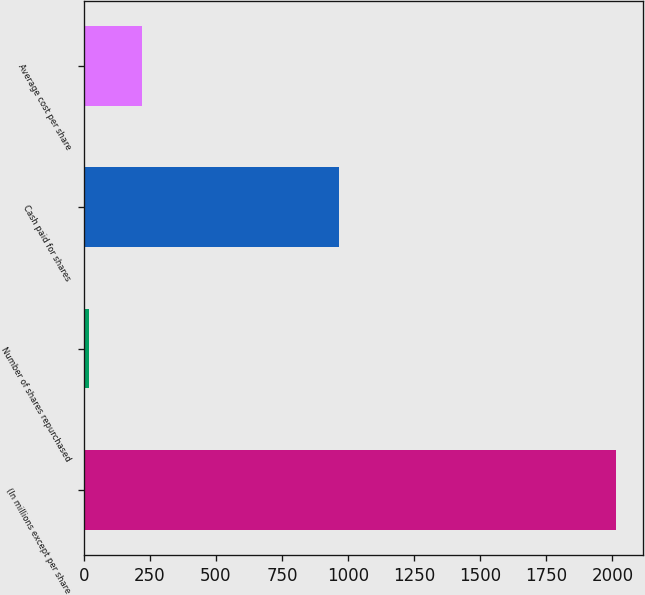<chart> <loc_0><loc_0><loc_500><loc_500><bar_chart><fcel>(In millions except per share<fcel>Number of shares repurchased<fcel>Cash paid for shares<fcel>Average cost per share<nl><fcel>2015<fcel>19<fcel>965<fcel>218.6<nl></chart> 